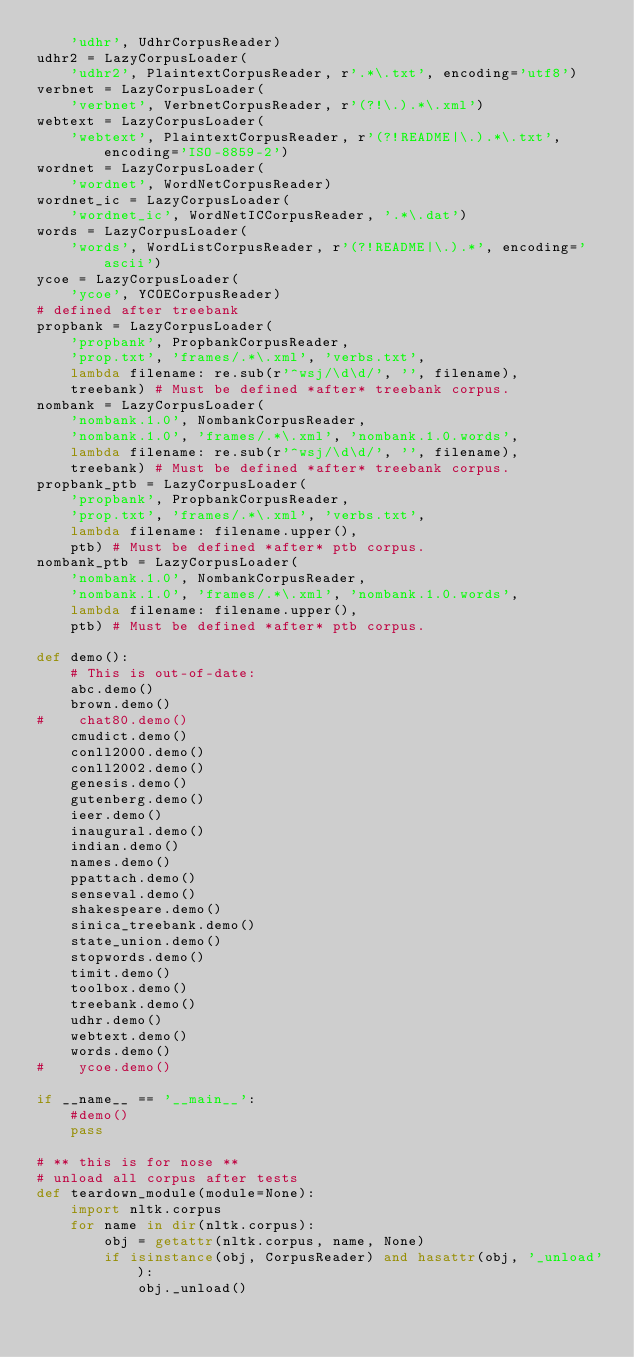<code> <loc_0><loc_0><loc_500><loc_500><_Python_>    'udhr', UdhrCorpusReader)
udhr2 = LazyCorpusLoader(
    'udhr2', PlaintextCorpusReader, r'.*\.txt', encoding='utf8')
verbnet = LazyCorpusLoader(
    'verbnet', VerbnetCorpusReader, r'(?!\.).*\.xml')
webtext = LazyCorpusLoader(
    'webtext', PlaintextCorpusReader, r'(?!README|\.).*\.txt', encoding='ISO-8859-2')
wordnet = LazyCorpusLoader(
    'wordnet', WordNetCorpusReader)
wordnet_ic = LazyCorpusLoader(
    'wordnet_ic', WordNetICCorpusReader, '.*\.dat')
words = LazyCorpusLoader(
    'words', WordListCorpusReader, r'(?!README|\.).*', encoding='ascii')
ycoe = LazyCorpusLoader(
    'ycoe', YCOECorpusReader)
# defined after treebank
propbank = LazyCorpusLoader(
    'propbank', PropbankCorpusReader,
    'prop.txt', 'frames/.*\.xml', 'verbs.txt',
    lambda filename: re.sub(r'^wsj/\d\d/', '', filename),
    treebank) # Must be defined *after* treebank corpus.
nombank = LazyCorpusLoader(
    'nombank.1.0', NombankCorpusReader,
    'nombank.1.0', 'frames/.*\.xml', 'nombank.1.0.words',
    lambda filename: re.sub(r'^wsj/\d\d/', '', filename),
    treebank) # Must be defined *after* treebank corpus.
propbank_ptb = LazyCorpusLoader(
    'propbank', PropbankCorpusReader,
    'prop.txt', 'frames/.*\.xml', 'verbs.txt',
    lambda filename: filename.upper(),
    ptb) # Must be defined *after* ptb corpus.
nombank_ptb = LazyCorpusLoader(
    'nombank.1.0', NombankCorpusReader,
    'nombank.1.0', 'frames/.*\.xml', 'nombank.1.0.words',
    lambda filename: filename.upper(),
    ptb) # Must be defined *after* ptb corpus.

def demo():
    # This is out-of-date:
    abc.demo()
    brown.demo()
#    chat80.demo()
    cmudict.demo()
    conll2000.demo()
    conll2002.demo()
    genesis.demo()
    gutenberg.demo()
    ieer.demo()
    inaugural.demo()
    indian.demo()
    names.demo()
    ppattach.demo()
    senseval.demo()
    shakespeare.demo()
    sinica_treebank.demo()
    state_union.demo()
    stopwords.demo()
    timit.demo()
    toolbox.demo()
    treebank.demo()
    udhr.demo()
    webtext.demo()
    words.demo()
#    ycoe.demo()

if __name__ == '__main__':
    #demo()
    pass

# ** this is for nose **
# unload all corpus after tests
def teardown_module(module=None):
    import nltk.corpus
    for name in dir(nltk.corpus):
        obj = getattr(nltk.corpus, name, None)
        if isinstance(obj, CorpusReader) and hasattr(obj, '_unload'):
            obj._unload()
</code> 